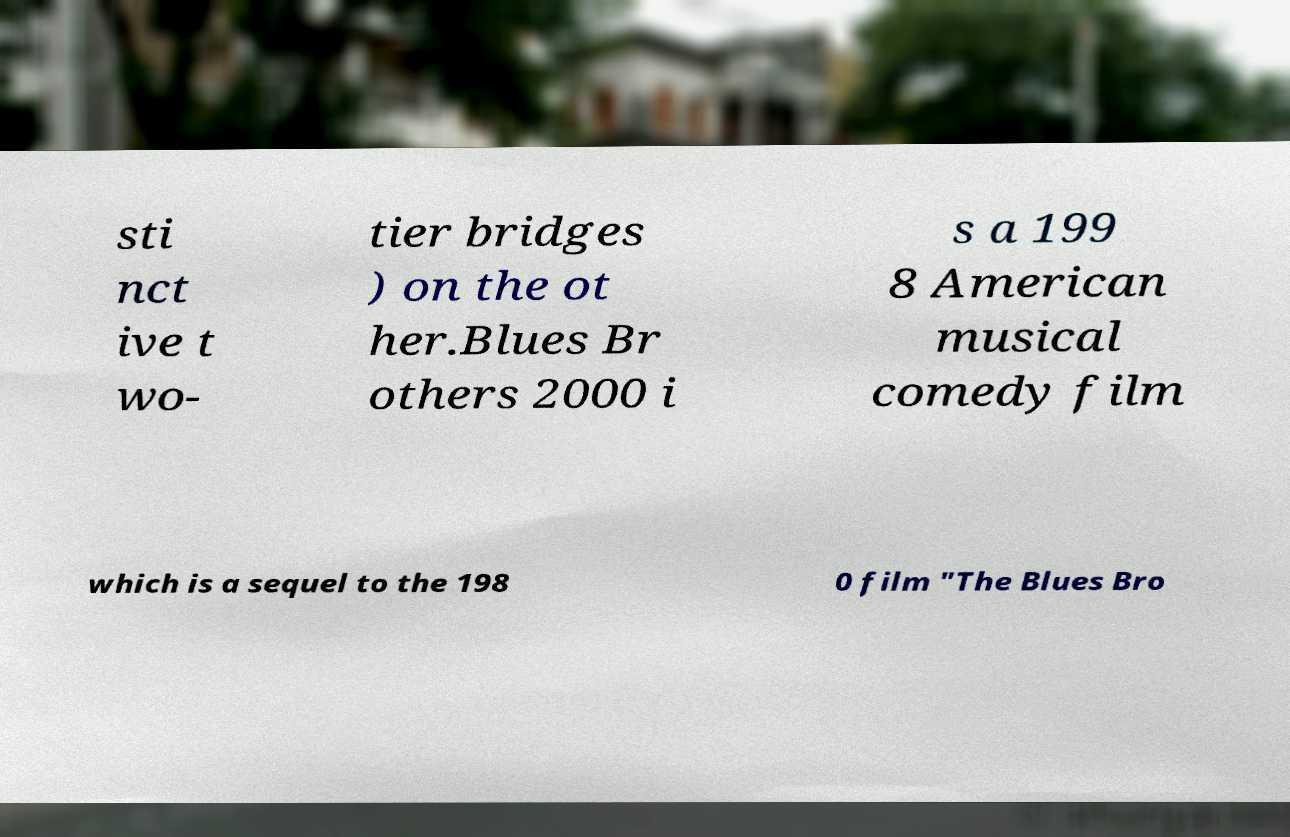I need the written content from this picture converted into text. Can you do that? sti nct ive t wo- tier bridges ) on the ot her.Blues Br others 2000 i s a 199 8 American musical comedy film which is a sequel to the 198 0 film "The Blues Bro 